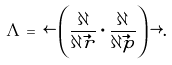Convert formula to latex. <formula><loc_0><loc_0><loc_500><loc_500>\Lambda = \, \leftarrow \left ( \frac { \partial } { \partial \vec { r } } \cdot \frac { \partial } { \partial \vec { p } } \right ) \rightarrow .</formula> 